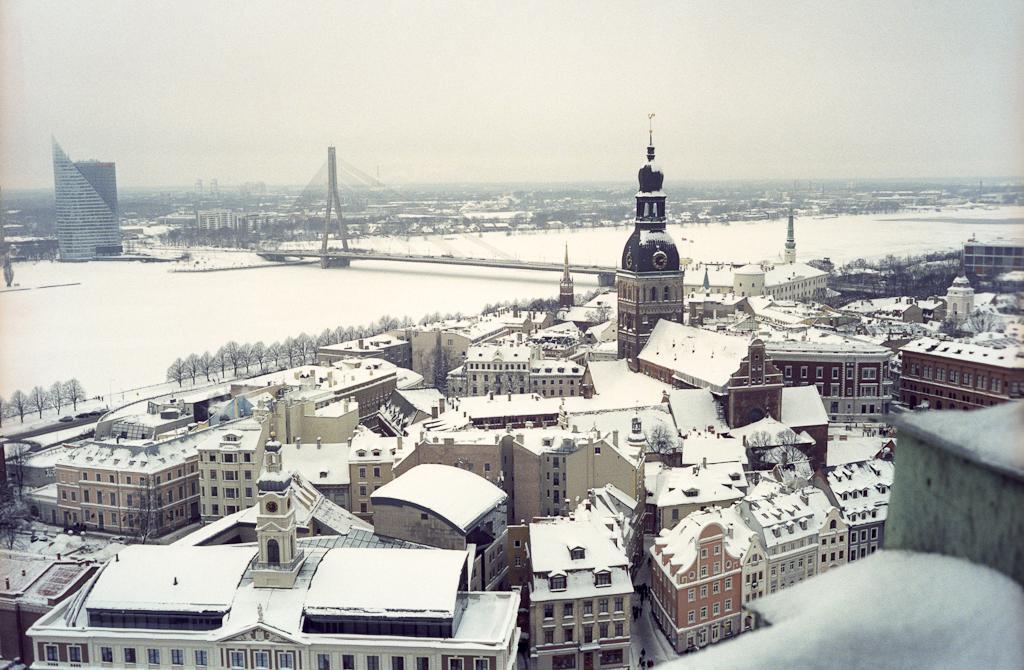Please provide a concise description of this image. In this image, we see some buildings and there is also a road, there are some trees and there are also windows to the buildings. There is a bridge across the snow and there is also sky. 